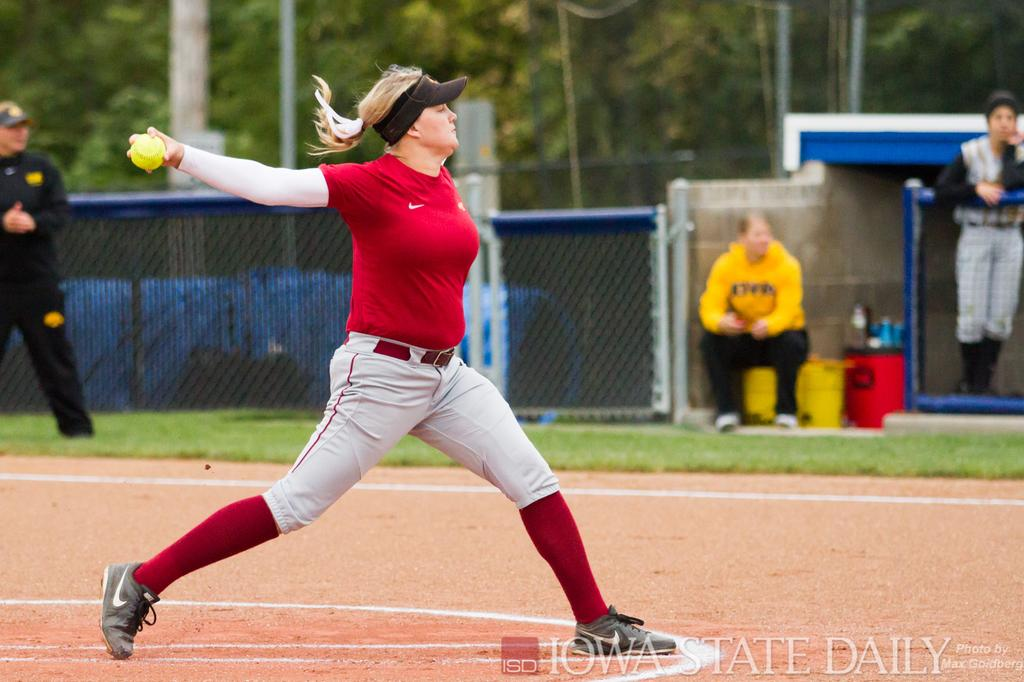<image>
Provide a brief description of the given image. A woman gets ready to throw a softball in a photo by Iowa State Daily. 